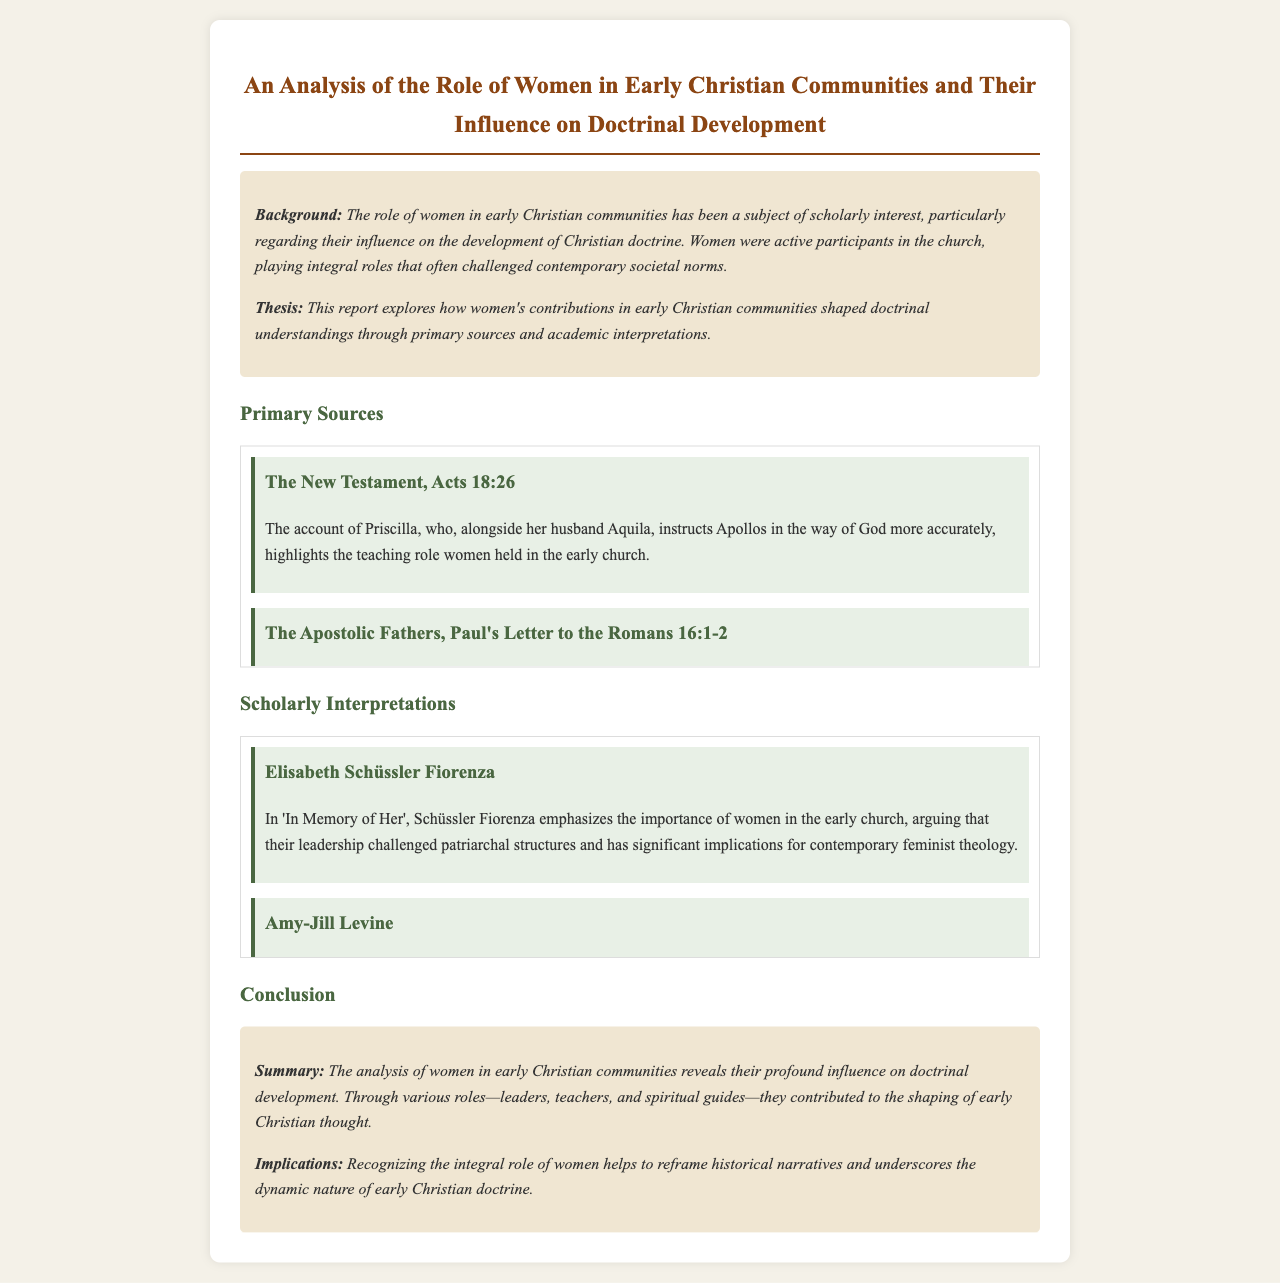What role did Priscilla play in the early church? Priscilla instructed Apollos in the way of God more accurately, highlighting her teaching role.
Answer: Teaching Which letter refers to Phoebe as a deacon? Paul's Letter to the Romans identifies Phoebe as a deacon of the church in Cenchreae.
Answer: Romans 16:1-2 Who authored "In Memory of Her"? Elisabeth Schüssler Fiorenza wrote "In Memory of Her," emphasizing women's importance in the early church.
Answer: Elisabeth Schüssler Fiorenza What is the implication of women's voices in early Christian texts according to Karen L. King? Karen L. King suggests women's teachings were foundational yet marginalized in later doctrinal formulations.
Answer: Marginalized What is the main thesis of the report? The report explores how women's contributions in early Christian communities shaped doctrinal understandings.
Answer: Women’s contributions shaped doctrinal understandings 